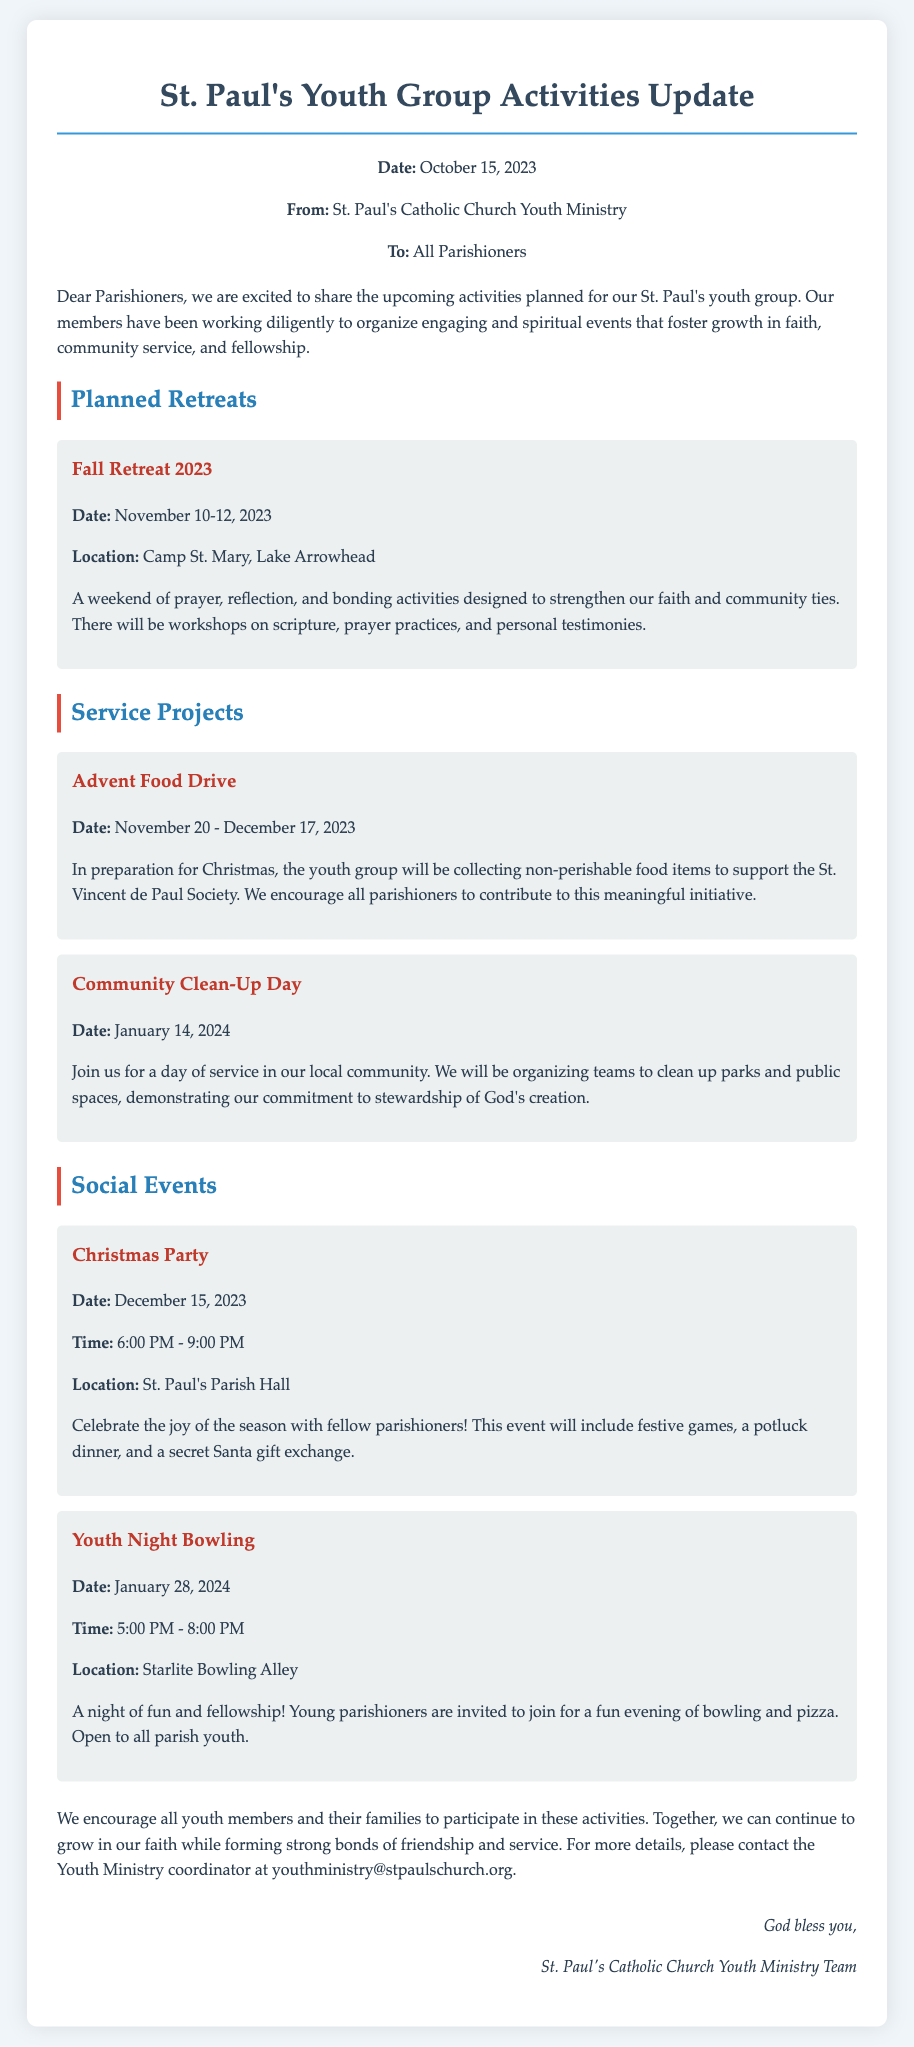What are the dates for the Fall Retreat 2023? The Fall Retreat 2023 is scheduled for November 10-12, 2023.
Answer: November 10-12, 2023 What is the location of the Fall Retreat? The memo states that the Fall Retreat will be held at Camp St. Mary, Lake Arrowhead.
Answer: Camp St. Mary, Lake Arrowhead What is the purpose of the Advent Food Drive? The Advent Food Drive aims to collect non-perishable food items to support the St. Vincent de Paul Society.
Answer: Support the St. Vincent de Paul Society When is the Community Clean-Up Day? The Community Clean-Up Day is set for January 14, 2024, as mentioned in the document.
Answer: January 14, 2024 What time will the Christmas Party take place? The Christmas Party is scheduled from 6:00 PM to 9:00 PM, according to the memo.
Answer: 6:00 PM - 9:00 PM What type of activities will be included in the Fall Retreat? The Fall Retreat will include prayer, reflection, and bonding activities, as detailed in the document.
Answer: Prayer, reflection, and bonding activities Who is encouraged to participate in the youth group activities? The memo encourages all youth members and their families to participate in the activities.
Answer: All youth members and their families What is the format of the Youth Night Bowling event? The Youth Night Bowling event is described as a fun evening of bowling and pizza.
Answer: Bowling and pizza What type of dinner will be part of the Christmas Party? The memo mentions that there will be a potluck dinner during the Christmas Party.
Answer: Potluck dinner 